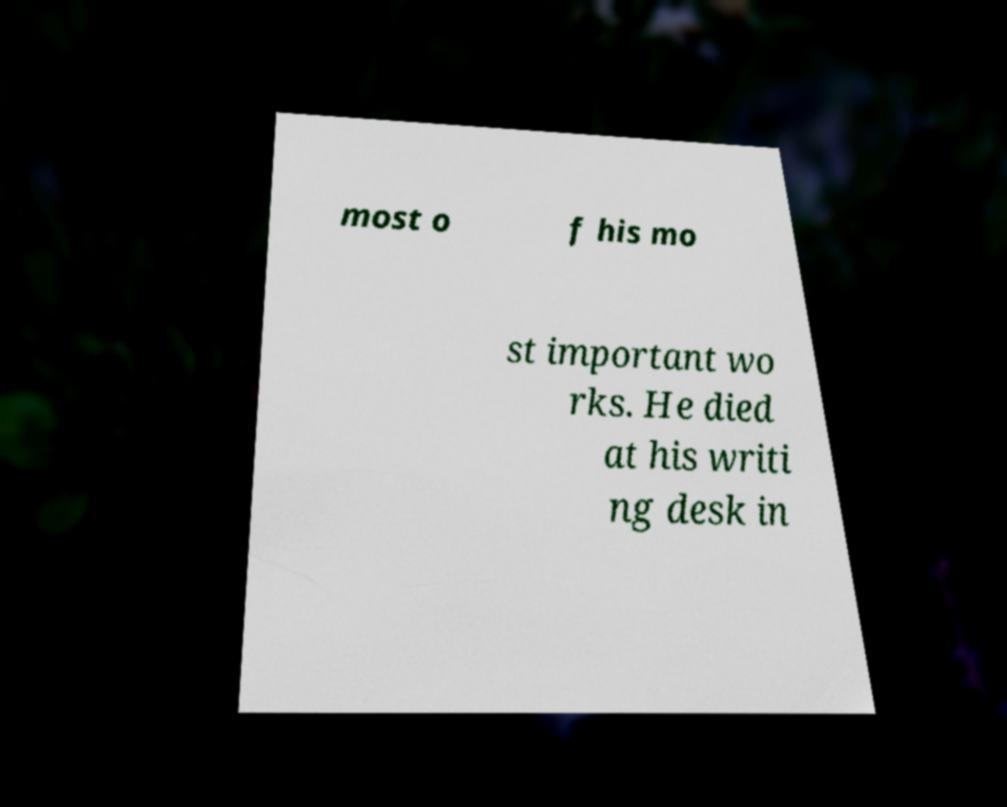Please identify and transcribe the text found in this image. most o f his mo st important wo rks. He died at his writi ng desk in 